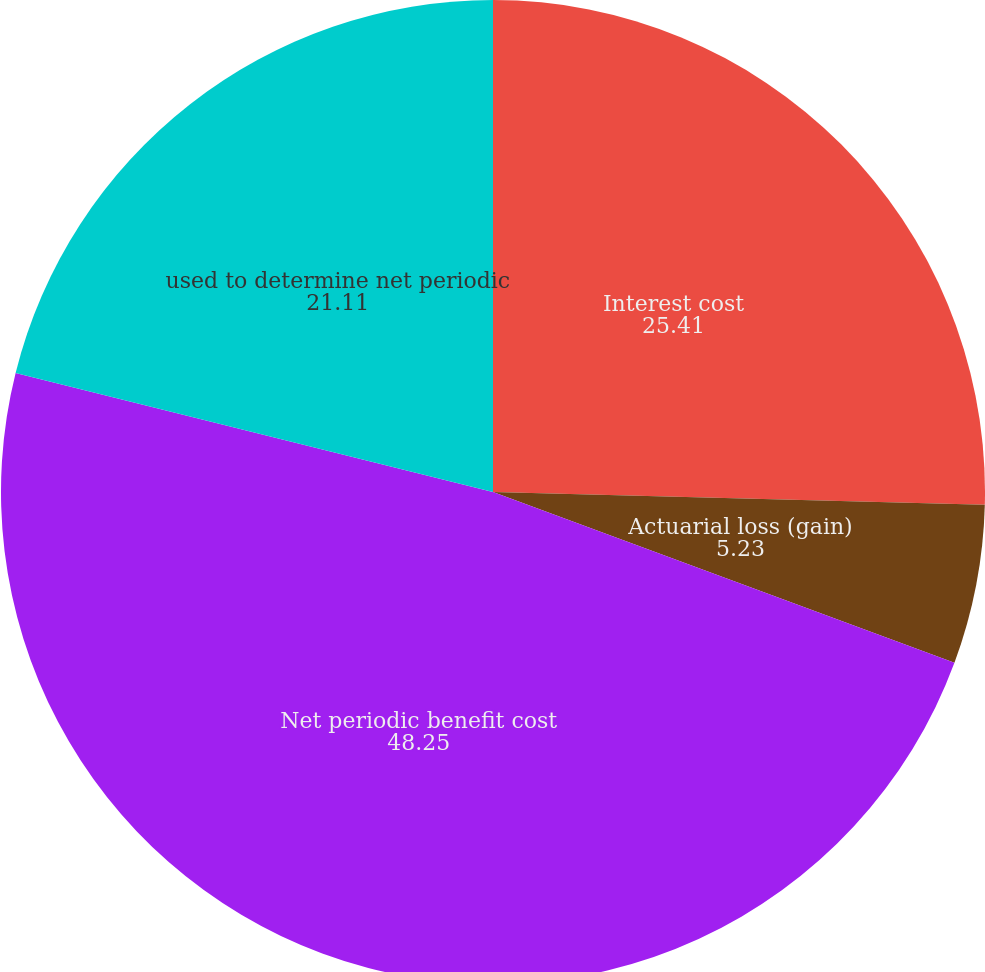Convert chart to OTSL. <chart><loc_0><loc_0><loc_500><loc_500><pie_chart><fcel>Interest cost<fcel>Actuarial loss (gain)<fcel>Net periodic benefit cost<fcel>used to determine net periodic<nl><fcel>25.41%<fcel>5.23%<fcel>48.25%<fcel>21.11%<nl></chart> 